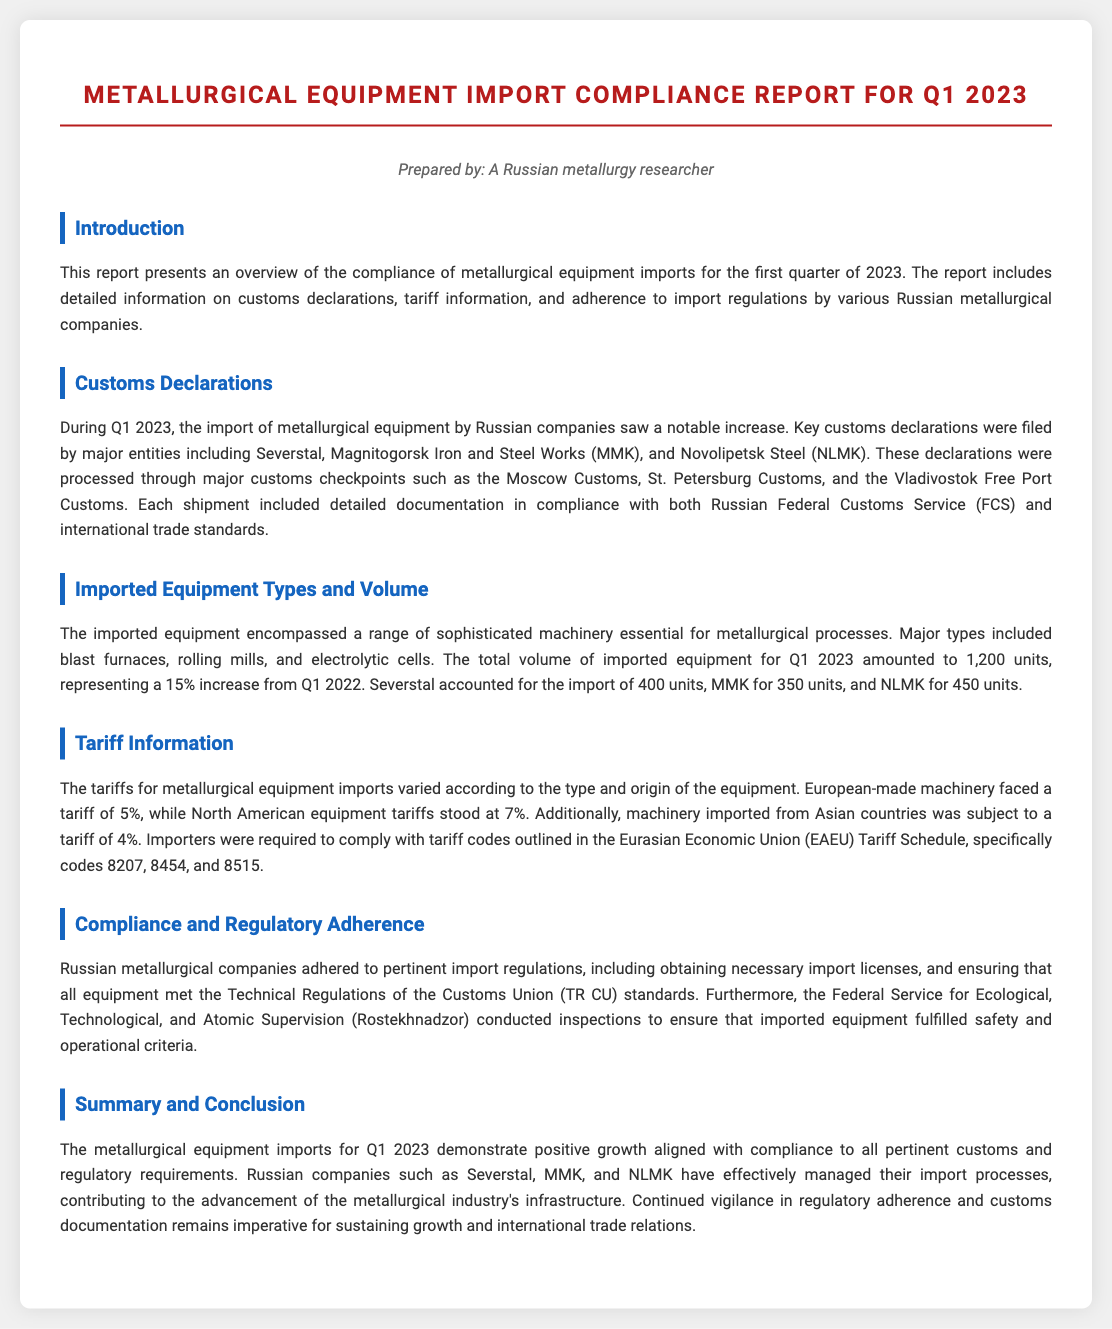What was the total volume of imported equipment for Q1 2023? The total volume of imported equipment is specified as 1,200 units.
Answer: 1,200 units Which companies filed key customs declarations during Q1 2023? The companies mentioned in the customs declarations are Severstal, Magnitogorsk Iron and Steel Works (MMK), and Novolipetsk Steel (NLMK).
Answer: Severstal, MMK, NLMK What was the tariff percentage for European-made machinery? The document states that European-made machinery faced a tariff of 5%.
Answer: 5% How much equipment did MMK import in Q1 2023? The document indicates that MMK accounted for the import of 350 units.
Answer: 350 units What was the increase percentage in imported equipment volume from Q1 2022 to Q1 2023? It is mentioned that there was a 15% increase in the volume of imported equipment compared to Q1 2022.
Answer: 15% What standards must imported equipment meet according to the report? The report mentions that equipment must meet the Technical Regulations of the Customs Union (TR CU) standards.
Answer: TR CU Which customs checkpoints processed the shipments? The document lists Moscow Customs, St. Petersburg Customs, and Vladivostok Free Port Customs as the checkpoints.
Answer: Moscow Customs, St. Petersburg Customs, Vladivostok Free Port Customs What type of machinery faced a tariff of 4%? The document states that machinery imported from Asian countries was subject to a tariff of 4%.
Answer: Asian countries 